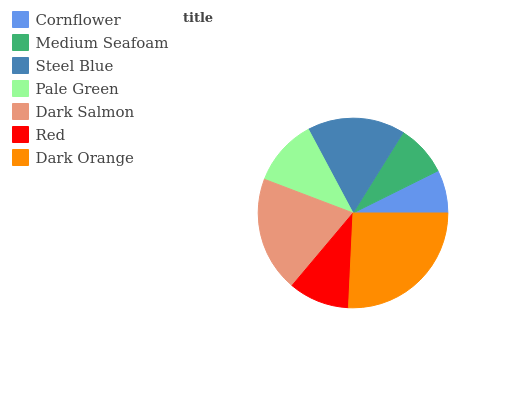Is Cornflower the minimum?
Answer yes or no. Yes. Is Dark Orange the maximum?
Answer yes or no. Yes. Is Medium Seafoam the minimum?
Answer yes or no. No. Is Medium Seafoam the maximum?
Answer yes or no. No. Is Medium Seafoam greater than Cornflower?
Answer yes or no. Yes. Is Cornflower less than Medium Seafoam?
Answer yes or no. Yes. Is Cornflower greater than Medium Seafoam?
Answer yes or no. No. Is Medium Seafoam less than Cornflower?
Answer yes or no. No. Is Pale Green the high median?
Answer yes or no. Yes. Is Pale Green the low median?
Answer yes or no. Yes. Is Cornflower the high median?
Answer yes or no. No. Is Steel Blue the low median?
Answer yes or no. No. 